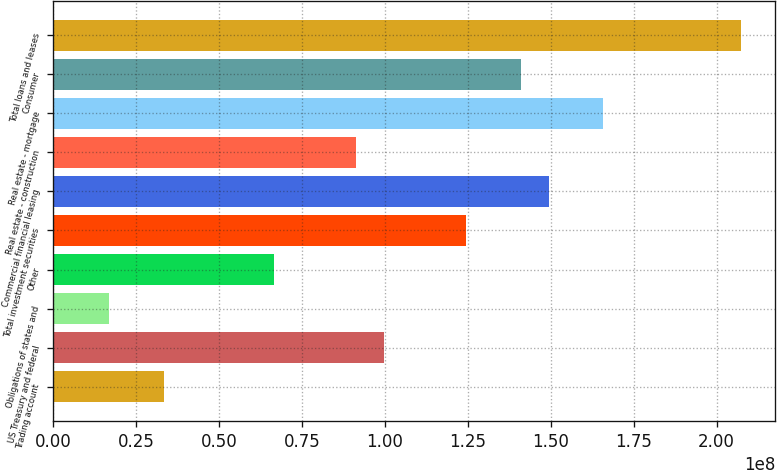Convert chart. <chart><loc_0><loc_0><loc_500><loc_500><bar_chart><fcel>Trading account<fcel>US Treasury and federal<fcel>Obligations of states and<fcel>Other<fcel>Total investment securities<fcel>Commercial financial leasing<fcel>Real estate - construction<fcel>Real estate - mortgage<fcel>Consumer<fcel>Total loans and leases<nl><fcel>3.32661e+07<fcel>9.95897e+07<fcel>1.66852e+07<fcel>6.64279e+07<fcel>1.24461e+08<fcel>1.49332e+08<fcel>9.12993e+07<fcel>1.65913e+08<fcel>1.41042e+08<fcel>2.07366e+08<nl></chart> 